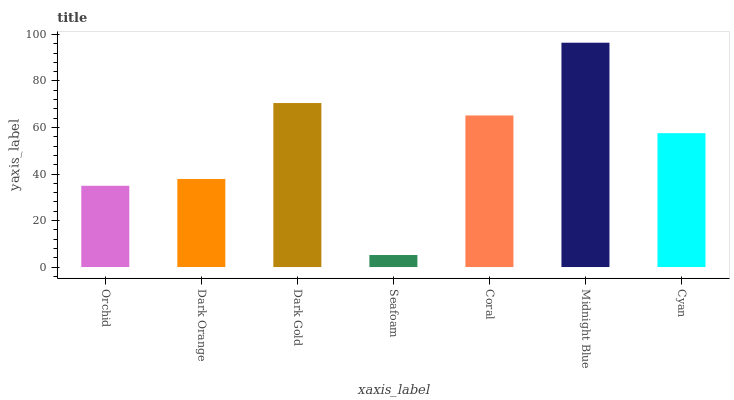Is Seafoam the minimum?
Answer yes or no. Yes. Is Midnight Blue the maximum?
Answer yes or no. Yes. Is Dark Orange the minimum?
Answer yes or no. No. Is Dark Orange the maximum?
Answer yes or no. No. Is Dark Orange greater than Orchid?
Answer yes or no. Yes. Is Orchid less than Dark Orange?
Answer yes or no. Yes. Is Orchid greater than Dark Orange?
Answer yes or no. No. Is Dark Orange less than Orchid?
Answer yes or no. No. Is Cyan the high median?
Answer yes or no. Yes. Is Cyan the low median?
Answer yes or no. Yes. Is Dark Orange the high median?
Answer yes or no. No. Is Dark Orange the low median?
Answer yes or no. No. 